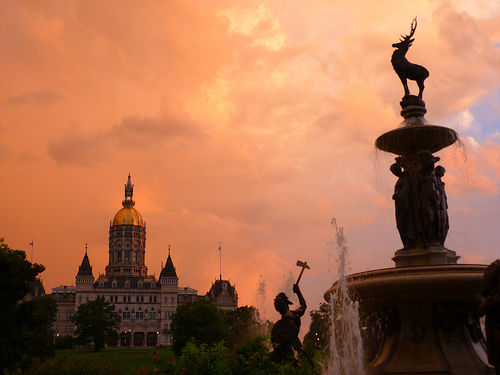<image>
Can you confirm if the figure is in front of the large statue? No. The figure is not in front of the large statue. The spatial positioning shows a different relationship between these objects. 